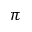<formula> <loc_0><loc_0><loc_500><loc_500>\pi</formula> 